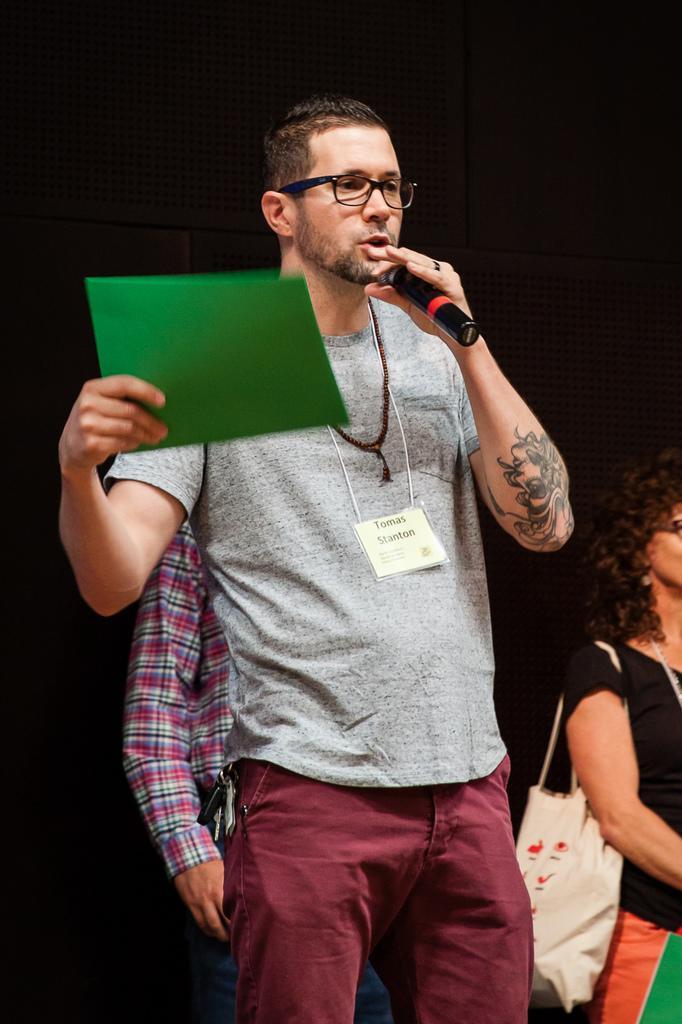Describe this image in one or two sentences. There is a man standing in the center and he is holding a microphone in his left hand and a file in his right hand and he is talking. There is a woman on the right side. 